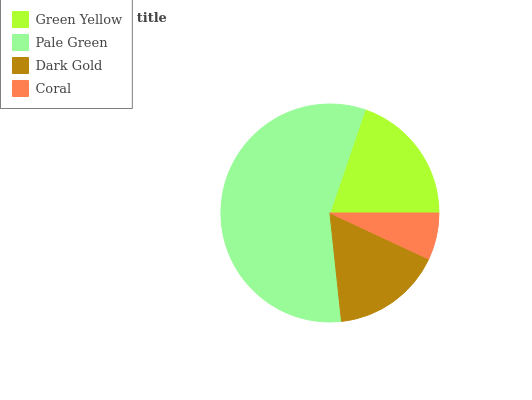Is Coral the minimum?
Answer yes or no. Yes. Is Pale Green the maximum?
Answer yes or no. Yes. Is Dark Gold the minimum?
Answer yes or no. No. Is Dark Gold the maximum?
Answer yes or no. No. Is Pale Green greater than Dark Gold?
Answer yes or no. Yes. Is Dark Gold less than Pale Green?
Answer yes or no. Yes. Is Dark Gold greater than Pale Green?
Answer yes or no. No. Is Pale Green less than Dark Gold?
Answer yes or no. No. Is Green Yellow the high median?
Answer yes or no. Yes. Is Dark Gold the low median?
Answer yes or no. Yes. Is Coral the high median?
Answer yes or no. No. Is Green Yellow the low median?
Answer yes or no. No. 